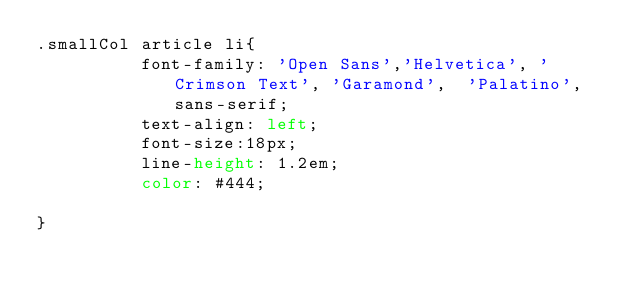Convert code to text. <code><loc_0><loc_0><loc_500><loc_500><_CSS_>.smallCol article li{
          font-family: 'Open Sans','Helvetica', 'Crimson Text', 'Garamond',  'Palatino', sans-serif;
          text-align: left;
          font-size:18px;
          line-height: 1.2em;
          color: #444;
    
}</code> 